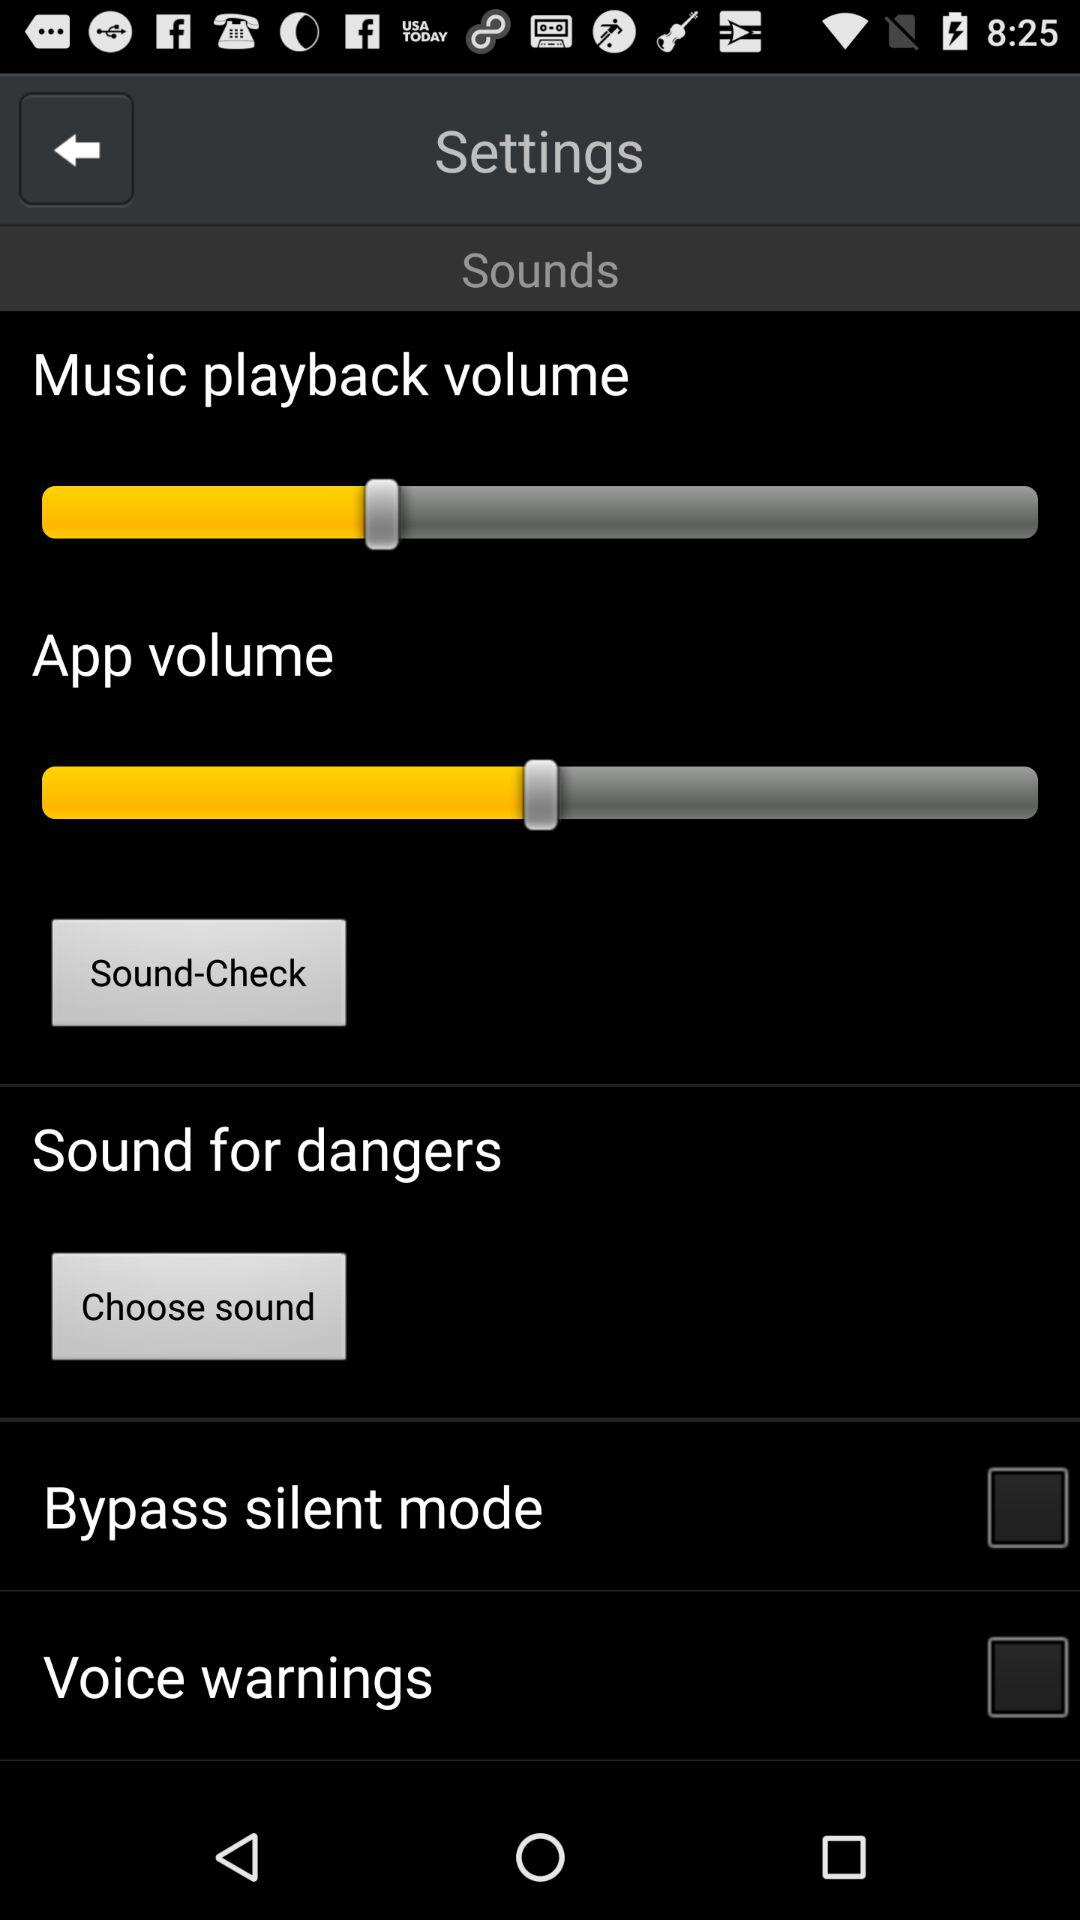What is the status of the "Bypass silent mode"? The status is "off". 